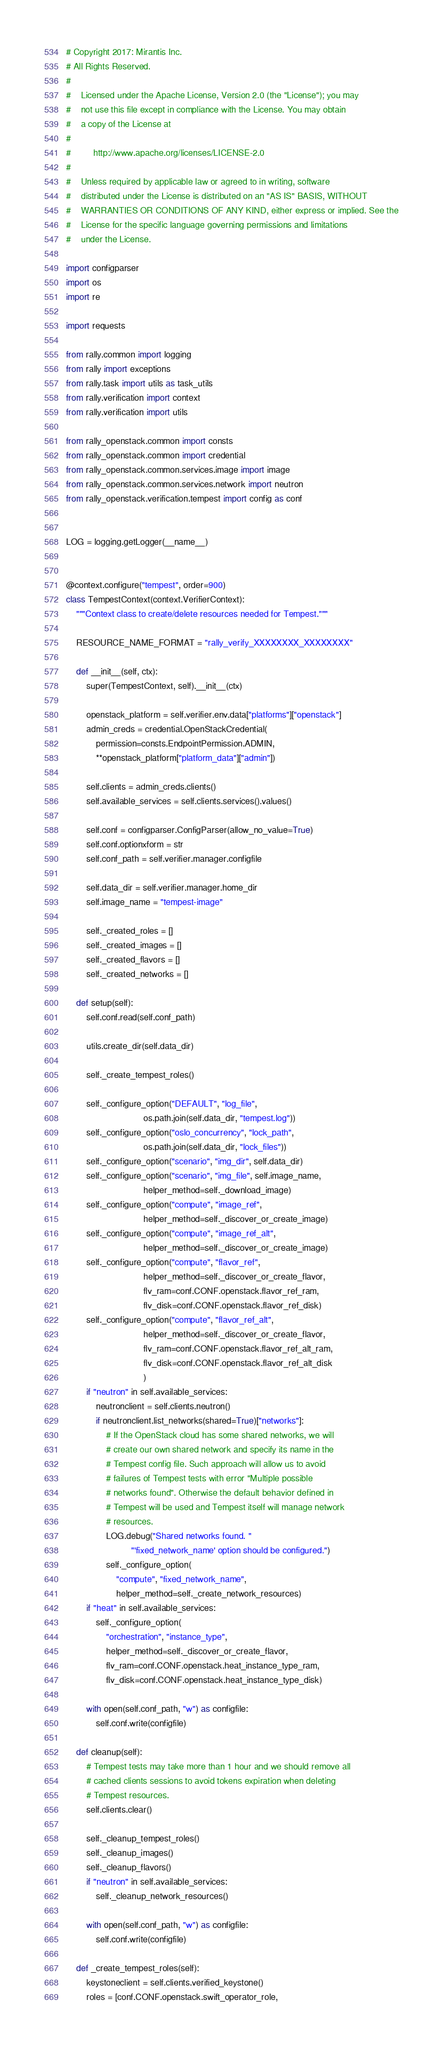<code> <loc_0><loc_0><loc_500><loc_500><_Python_># Copyright 2017: Mirantis Inc.
# All Rights Reserved.
#
#    Licensed under the Apache License, Version 2.0 (the "License"); you may
#    not use this file except in compliance with the License. You may obtain
#    a copy of the License at
#
#         http://www.apache.org/licenses/LICENSE-2.0
#
#    Unless required by applicable law or agreed to in writing, software
#    distributed under the License is distributed on an "AS IS" BASIS, WITHOUT
#    WARRANTIES OR CONDITIONS OF ANY KIND, either express or implied. See the
#    License for the specific language governing permissions and limitations
#    under the License.

import configparser
import os
import re

import requests

from rally.common import logging
from rally import exceptions
from rally.task import utils as task_utils
from rally.verification import context
from rally.verification import utils

from rally_openstack.common import consts
from rally_openstack.common import credential
from rally_openstack.common.services.image import image
from rally_openstack.common.services.network import neutron
from rally_openstack.verification.tempest import config as conf


LOG = logging.getLogger(__name__)


@context.configure("tempest", order=900)
class TempestContext(context.VerifierContext):
    """Context class to create/delete resources needed for Tempest."""

    RESOURCE_NAME_FORMAT = "rally_verify_XXXXXXXX_XXXXXXXX"

    def __init__(self, ctx):
        super(TempestContext, self).__init__(ctx)

        openstack_platform = self.verifier.env.data["platforms"]["openstack"]
        admin_creds = credential.OpenStackCredential(
            permission=consts.EndpointPermission.ADMIN,
            **openstack_platform["platform_data"]["admin"])

        self.clients = admin_creds.clients()
        self.available_services = self.clients.services().values()

        self.conf = configparser.ConfigParser(allow_no_value=True)
        self.conf.optionxform = str
        self.conf_path = self.verifier.manager.configfile

        self.data_dir = self.verifier.manager.home_dir
        self.image_name = "tempest-image"

        self._created_roles = []
        self._created_images = []
        self._created_flavors = []
        self._created_networks = []

    def setup(self):
        self.conf.read(self.conf_path)

        utils.create_dir(self.data_dir)

        self._create_tempest_roles()

        self._configure_option("DEFAULT", "log_file",
                               os.path.join(self.data_dir, "tempest.log"))
        self._configure_option("oslo_concurrency", "lock_path",
                               os.path.join(self.data_dir, "lock_files"))
        self._configure_option("scenario", "img_dir", self.data_dir)
        self._configure_option("scenario", "img_file", self.image_name,
                               helper_method=self._download_image)
        self._configure_option("compute", "image_ref",
                               helper_method=self._discover_or_create_image)
        self._configure_option("compute", "image_ref_alt",
                               helper_method=self._discover_or_create_image)
        self._configure_option("compute", "flavor_ref",
                               helper_method=self._discover_or_create_flavor,
                               flv_ram=conf.CONF.openstack.flavor_ref_ram,
                               flv_disk=conf.CONF.openstack.flavor_ref_disk)
        self._configure_option("compute", "flavor_ref_alt",
                               helper_method=self._discover_or_create_flavor,
                               flv_ram=conf.CONF.openstack.flavor_ref_alt_ram,
                               flv_disk=conf.CONF.openstack.flavor_ref_alt_disk
                               )
        if "neutron" in self.available_services:
            neutronclient = self.clients.neutron()
            if neutronclient.list_networks(shared=True)["networks"]:
                # If the OpenStack cloud has some shared networks, we will
                # create our own shared network and specify its name in the
                # Tempest config file. Such approach will allow us to avoid
                # failures of Tempest tests with error "Multiple possible
                # networks found". Otherwise the default behavior defined in
                # Tempest will be used and Tempest itself will manage network
                # resources.
                LOG.debug("Shared networks found. "
                          "'fixed_network_name' option should be configured.")
                self._configure_option(
                    "compute", "fixed_network_name",
                    helper_method=self._create_network_resources)
        if "heat" in self.available_services:
            self._configure_option(
                "orchestration", "instance_type",
                helper_method=self._discover_or_create_flavor,
                flv_ram=conf.CONF.openstack.heat_instance_type_ram,
                flv_disk=conf.CONF.openstack.heat_instance_type_disk)

        with open(self.conf_path, "w") as configfile:
            self.conf.write(configfile)

    def cleanup(self):
        # Tempest tests may take more than 1 hour and we should remove all
        # cached clients sessions to avoid tokens expiration when deleting
        # Tempest resources.
        self.clients.clear()

        self._cleanup_tempest_roles()
        self._cleanup_images()
        self._cleanup_flavors()
        if "neutron" in self.available_services:
            self._cleanup_network_resources()

        with open(self.conf_path, "w") as configfile:
            self.conf.write(configfile)

    def _create_tempest_roles(self):
        keystoneclient = self.clients.verified_keystone()
        roles = [conf.CONF.openstack.swift_operator_role,</code> 